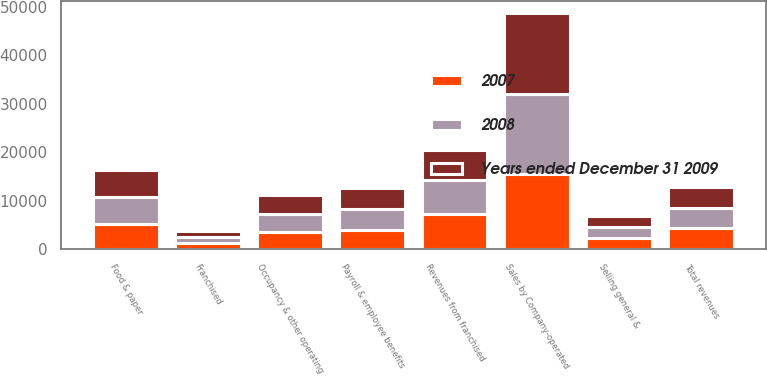Convert chart to OTSL. <chart><loc_0><loc_0><loc_500><loc_500><stacked_bar_chart><ecel><fcel>Sales by Company-operated<fcel>Revenues from franchised<fcel>Total revenues<fcel>Food & paper<fcel>Payroll & employee benefits<fcel>Occupancy & other operating<fcel>Franchised<fcel>Selling general &<nl><fcel>2007<fcel>15458.5<fcel>7286.2<fcel>4300.1<fcel>5178<fcel>3965.6<fcel>3507.6<fcel>1301.7<fcel>2234.2<nl><fcel>2008<fcel>16560.9<fcel>6961.5<fcel>4300.1<fcel>5586.1<fcel>4300.1<fcel>3766.7<fcel>1230.3<fcel>2355.5<nl><fcel>Years ended December 31 2009<fcel>16611<fcel>6175.6<fcel>4300.1<fcel>5487.4<fcel>4331.6<fcel>3922.7<fcel>1139.7<fcel>2367<nl></chart> 